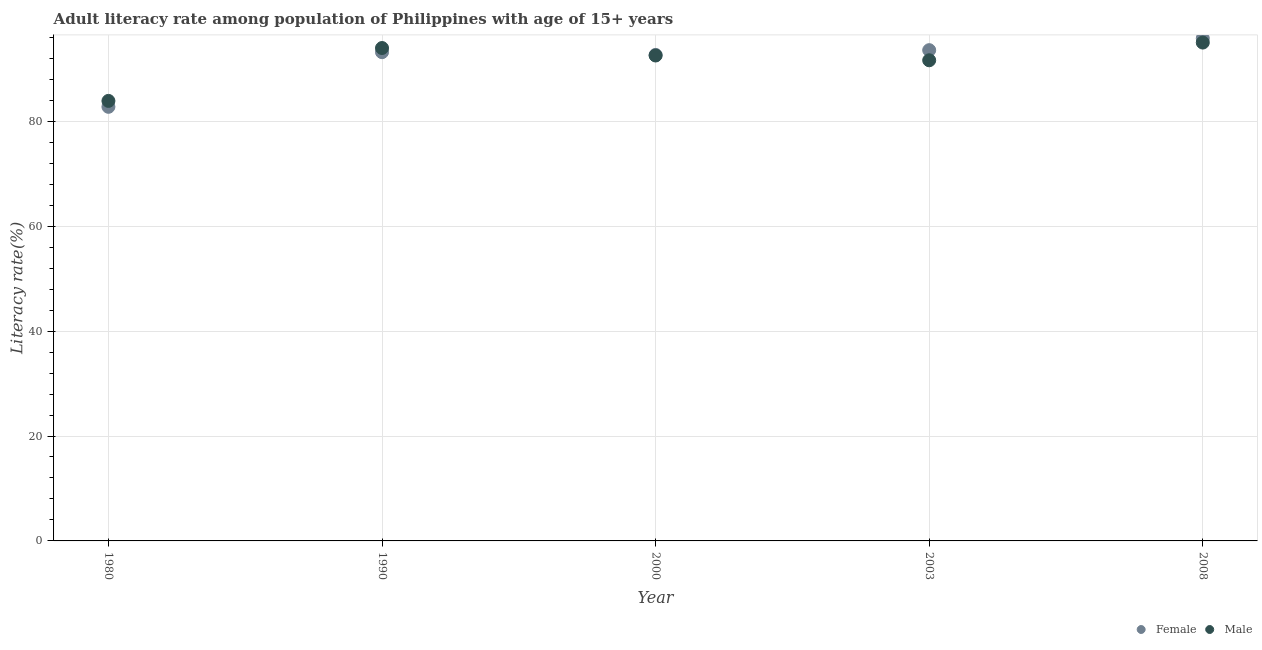How many different coloured dotlines are there?
Offer a terse response. 2. What is the male adult literacy rate in 2000?
Keep it short and to the point. 92.54. Across all years, what is the maximum female adult literacy rate?
Offer a very short reply. 95.83. Across all years, what is the minimum female adult literacy rate?
Give a very brief answer. 82.76. In which year was the female adult literacy rate maximum?
Your answer should be compact. 2008. What is the total female adult literacy rate in the graph?
Offer a very short reply. 457.99. What is the difference between the male adult literacy rate in 2000 and that in 2008?
Give a very brief answer. -2.47. What is the difference between the male adult literacy rate in 2000 and the female adult literacy rate in 2008?
Offer a very short reply. -3.28. What is the average male adult literacy rate per year?
Your response must be concise. 91.41. In the year 2003, what is the difference between the male adult literacy rate and female adult literacy rate?
Give a very brief answer. -1.93. In how many years, is the female adult literacy rate greater than 28 %?
Your response must be concise. 5. What is the ratio of the male adult literacy rate in 1990 to that in 2003?
Offer a very short reply. 1.03. What is the difference between the highest and the second highest female adult literacy rate?
Your response must be concise. 2.26. What is the difference between the highest and the lowest male adult literacy rate?
Your answer should be compact. 11.12. Is the sum of the male adult literacy rate in 1980 and 1990 greater than the maximum female adult literacy rate across all years?
Provide a short and direct response. Yes. Does the male adult literacy rate monotonically increase over the years?
Give a very brief answer. No. Is the male adult literacy rate strictly greater than the female adult literacy rate over the years?
Your response must be concise. No. Is the female adult literacy rate strictly less than the male adult literacy rate over the years?
Your answer should be compact. No. How many years are there in the graph?
Your response must be concise. 5. Does the graph contain any zero values?
Your answer should be compact. No. Where does the legend appear in the graph?
Your answer should be very brief. Bottom right. How many legend labels are there?
Offer a terse response. 2. How are the legend labels stacked?
Ensure brevity in your answer.  Horizontal. What is the title of the graph?
Provide a succinct answer. Adult literacy rate among population of Philippines with age of 15+ years. Does "Methane" appear as one of the legend labels in the graph?
Your answer should be compact. No. What is the label or title of the Y-axis?
Your response must be concise. Literacy rate(%). What is the Literacy rate(%) of Female in 1980?
Give a very brief answer. 82.76. What is the Literacy rate(%) in Male in 1980?
Offer a terse response. 83.89. What is the Literacy rate(%) of Female in 1990?
Your answer should be very brief. 93.18. What is the Literacy rate(%) in Male in 1990?
Make the answer very short. 93.97. What is the Literacy rate(%) of Female in 2000?
Keep it short and to the point. 92.65. What is the Literacy rate(%) in Male in 2000?
Provide a succinct answer. 92.54. What is the Literacy rate(%) in Female in 2003?
Your answer should be compact. 93.56. What is the Literacy rate(%) in Male in 2003?
Offer a very short reply. 91.63. What is the Literacy rate(%) in Female in 2008?
Ensure brevity in your answer.  95.83. What is the Literacy rate(%) in Male in 2008?
Keep it short and to the point. 95.01. Across all years, what is the maximum Literacy rate(%) in Female?
Make the answer very short. 95.83. Across all years, what is the maximum Literacy rate(%) in Male?
Your answer should be very brief. 95.01. Across all years, what is the minimum Literacy rate(%) of Female?
Offer a very short reply. 82.76. Across all years, what is the minimum Literacy rate(%) of Male?
Give a very brief answer. 83.89. What is the total Literacy rate(%) of Female in the graph?
Ensure brevity in your answer.  457.99. What is the total Literacy rate(%) of Male in the graph?
Ensure brevity in your answer.  457.05. What is the difference between the Literacy rate(%) in Female in 1980 and that in 1990?
Ensure brevity in your answer.  -10.42. What is the difference between the Literacy rate(%) of Male in 1980 and that in 1990?
Your answer should be compact. -10.08. What is the difference between the Literacy rate(%) in Female in 1980 and that in 2000?
Make the answer very short. -9.89. What is the difference between the Literacy rate(%) of Male in 1980 and that in 2000?
Provide a short and direct response. -8.66. What is the difference between the Literacy rate(%) of Female in 1980 and that in 2003?
Your answer should be very brief. -10.8. What is the difference between the Literacy rate(%) in Male in 1980 and that in 2003?
Your response must be concise. -7.75. What is the difference between the Literacy rate(%) of Female in 1980 and that in 2008?
Your response must be concise. -13.06. What is the difference between the Literacy rate(%) of Male in 1980 and that in 2008?
Offer a terse response. -11.12. What is the difference between the Literacy rate(%) in Female in 1990 and that in 2000?
Ensure brevity in your answer.  0.53. What is the difference between the Literacy rate(%) in Male in 1990 and that in 2000?
Offer a terse response. 1.43. What is the difference between the Literacy rate(%) of Female in 1990 and that in 2003?
Your response must be concise. -0.38. What is the difference between the Literacy rate(%) of Male in 1990 and that in 2003?
Offer a very short reply. 2.34. What is the difference between the Literacy rate(%) in Female in 1990 and that in 2008?
Make the answer very short. -2.64. What is the difference between the Literacy rate(%) in Male in 1990 and that in 2008?
Provide a short and direct response. -1.04. What is the difference between the Literacy rate(%) of Female in 2000 and that in 2003?
Your answer should be compact. -0.91. What is the difference between the Literacy rate(%) of Male in 2000 and that in 2003?
Provide a succinct answer. 0.91. What is the difference between the Literacy rate(%) in Female in 2000 and that in 2008?
Keep it short and to the point. -3.17. What is the difference between the Literacy rate(%) of Male in 2000 and that in 2008?
Provide a succinct answer. -2.47. What is the difference between the Literacy rate(%) in Female in 2003 and that in 2008?
Make the answer very short. -2.26. What is the difference between the Literacy rate(%) in Male in 2003 and that in 2008?
Provide a short and direct response. -3.38. What is the difference between the Literacy rate(%) in Female in 1980 and the Literacy rate(%) in Male in 1990?
Ensure brevity in your answer.  -11.21. What is the difference between the Literacy rate(%) in Female in 1980 and the Literacy rate(%) in Male in 2000?
Your answer should be very brief. -9.78. What is the difference between the Literacy rate(%) in Female in 1980 and the Literacy rate(%) in Male in 2003?
Provide a succinct answer. -8.87. What is the difference between the Literacy rate(%) of Female in 1980 and the Literacy rate(%) of Male in 2008?
Provide a short and direct response. -12.25. What is the difference between the Literacy rate(%) of Female in 1990 and the Literacy rate(%) of Male in 2000?
Make the answer very short. 0.64. What is the difference between the Literacy rate(%) in Female in 1990 and the Literacy rate(%) in Male in 2003?
Offer a terse response. 1.55. What is the difference between the Literacy rate(%) of Female in 1990 and the Literacy rate(%) of Male in 2008?
Your response must be concise. -1.83. What is the difference between the Literacy rate(%) of Female in 2000 and the Literacy rate(%) of Male in 2003?
Give a very brief answer. 1.02. What is the difference between the Literacy rate(%) in Female in 2000 and the Literacy rate(%) in Male in 2008?
Offer a terse response. -2.36. What is the difference between the Literacy rate(%) in Female in 2003 and the Literacy rate(%) in Male in 2008?
Ensure brevity in your answer.  -1.45. What is the average Literacy rate(%) in Female per year?
Keep it short and to the point. 91.6. What is the average Literacy rate(%) of Male per year?
Your answer should be compact. 91.41. In the year 1980, what is the difference between the Literacy rate(%) in Female and Literacy rate(%) in Male?
Make the answer very short. -1.13. In the year 1990, what is the difference between the Literacy rate(%) in Female and Literacy rate(%) in Male?
Your response must be concise. -0.79. In the year 2000, what is the difference between the Literacy rate(%) of Female and Literacy rate(%) of Male?
Provide a succinct answer. 0.11. In the year 2003, what is the difference between the Literacy rate(%) in Female and Literacy rate(%) in Male?
Your response must be concise. 1.93. In the year 2008, what is the difference between the Literacy rate(%) of Female and Literacy rate(%) of Male?
Ensure brevity in your answer.  0.81. What is the ratio of the Literacy rate(%) of Female in 1980 to that in 1990?
Offer a terse response. 0.89. What is the ratio of the Literacy rate(%) of Male in 1980 to that in 1990?
Offer a terse response. 0.89. What is the ratio of the Literacy rate(%) of Female in 1980 to that in 2000?
Keep it short and to the point. 0.89. What is the ratio of the Literacy rate(%) in Male in 1980 to that in 2000?
Provide a short and direct response. 0.91. What is the ratio of the Literacy rate(%) of Female in 1980 to that in 2003?
Your answer should be compact. 0.88. What is the ratio of the Literacy rate(%) in Male in 1980 to that in 2003?
Your answer should be very brief. 0.92. What is the ratio of the Literacy rate(%) of Female in 1980 to that in 2008?
Your answer should be compact. 0.86. What is the ratio of the Literacy rate(%) of Male in 1980 to that in 2008?
Your answer should be compact. 0.88. What is the ratio of the Literacy rate(%) of Male in 1990 to that in 2000?
Keep it short and to the point. 1.02. What is the ratio of the Literacy rate(%) in Female in 1990 to that in 2003?
Ensure brevity in your answer.  1. What is the ratio of the Literacy rate(%) in Male in 1990 to that in 2003?
Provide a succinct answer. 1.03. What is the ratio of the Literacy rate(%) in Female in 1990 to that in 2008?
Your answer should be compact. 0.97. What is the ratio of the Literacy rate(%) of Male in 1990 to that in 2008?
Provide a short and direct response. 0.99. What is the ratio of the Literacy rate(%) in Female in 2000 to that in 2003?
Ensure brevity in your answer.  0.99. What is the ratio of the Literacy rate(%) of Male in 2000 to that in 2003?
Keep it short and to the point. 1.01. What is the ratio of the Literacy rate(%) in Female in 2000 to that in 2008?
Your answer should be very brief. 0.97. What is the ratio of the Literacy rate(%) of Male in 2000 to that in 2008?
Your answer should be very brief. 0.97. What is the ratio of the Literacy rate(%) of Female in 2003 to that in 2008?
Offer a terse response. 0.98. What is the ratio of the Literacy rate(%) in Male in 2003 to that in 2008?
Your answer should be compact. 0.96. What is the difference between the highest and the second highest Literacy rate(%) in Female?
Your response must be concise. 2.26. What is the difference between the highest and the second highest Literacy rate(%) in Male?
Your answer should be very brief. 1.04. What is the difference between the highest and the lowest Literacy rate(%) in Female?
Provide a short and direct response. 13.06. What is the difference between the highest and the lowest Literacy rate(%) in Male?
Provide a succinct answer. 11.12. 